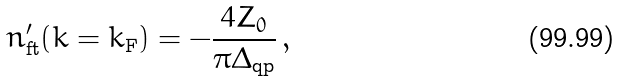Convert formula to latex. <formula><loc_0><loc_0><loc_500><loc_500>n ^ { \prime } _ { \text {ft} } ( k = k _ { \text {F} } ) = - \frac { 4 Z _ { 0 } } { \pi \Delta _ { \text {qp} } } \, ,</formula> 